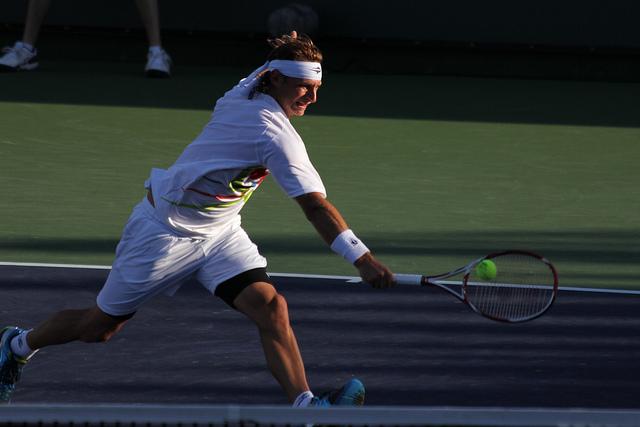Has the man in this picture hit the tennis ball yet?
Concise answer only. No. What hand is extended forward?
Keep it brief. Right. What is the player doing?
Concise answer only. Hitting ball. What is the logo on his socks?
Keep it brief. Adidas. Is it a man or woman?
Give a very brief answer. Man. Will the boy hit the ball?
Quick response, please. Yes. What direction is the player looking?
Write a very short answer. Down. What foot is close to the racket?
Write a very short answer. Left. What team is this player on?
Quick response, please. White team. Is the match over?
Give a very brief answer. No. Is he wearing a headband?
Quick response, please. Yes. What color are the gentlemen's shorts?
Be succinct. White. What emblem is on his headband, wristband and socks?
Give a very brief answer. Nike. 